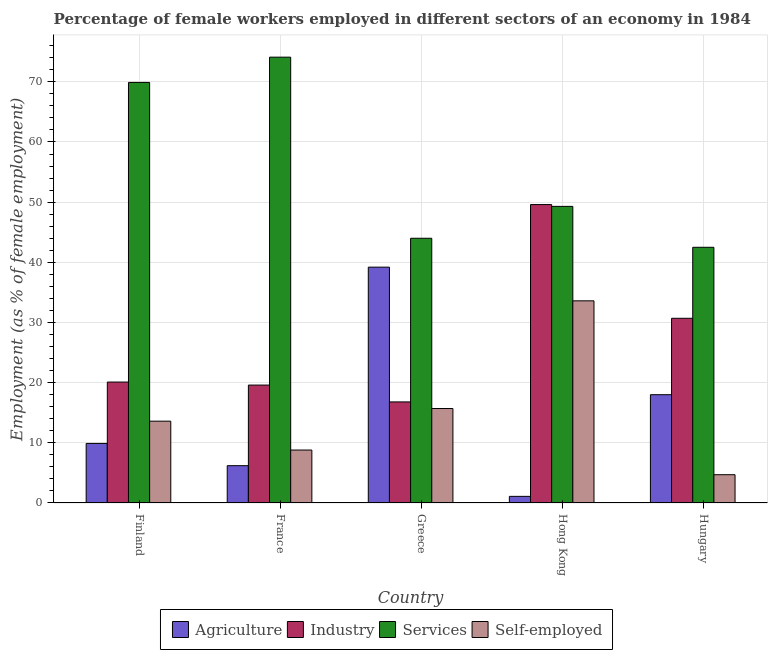Are the number of bars per tick equal to the number of legend labels?
Give a very brief answer. Yes. Are the number of bars on each tick of the X-axis equal?
Offer a terse response. Yes. How many bars are there on the 3rd tick from the right?
Offer a terse response. 4. What is the label of the 4th group of bars from the left?
Give a very brief answer. Hong Kong. In how many cases, is the number of bars for a given country not equal to the number of legend labels?
Make the answer very short. 0. What is the percentage of female workers in industry in Finland?
Your response must be concise. 20.1. Across all countries, what is the maximum percentage of female workers in services?
Your answer should be very brief. 74.1. Across all countries, what is the minimum percentage of female workers in industry?
Give a very brief answer. 16.8. In which country was the percentage of self employed female workers maximum?
Make the answer very short. Hong Kong. In which country was the percentage of female workers in services minimum?
Your answer should be very brief. Hungary. What is the total percentage of self employed female workers in the graph?
Offer a terse response. 76.4. What is the difference between the percentage of self employed female workers in Finland and that in Greece?
Ensure brevity in your answer.  -2.1. What is the difference between the percentage of self employed female workers in Hungary and the percentage of female workers in services in Finland?
Ensure brevity in your answer.  -65.2. What is the average percentage of female workers in agriculture per country?
Give a very brief answer. 14.88. What is the difference between the percentage of female workers in services and percentage of female workers in industry in Greece?
Make the answer very short. 27.2. What is the ratio of the percentage of female workers in services in Finland to that in Hungary?
Your response must be concise. 1.64. Is the percentage of female workers in industry in Finland less than that in Greece?
Provide a short and direct response. No. What is the difference between the highest and the second highest percentage of self employed female workers?
Keep it short and to the point. 17.9. What is the difference between the highest and the lowest percentage of female workers in services?
Make the answer very short. 31.6. Is it the case that in every country, the sum of the percentage of female workers in services and percentage of female workers in industry is greater than the sum of percentage of self employed female workers and percentage of female workers in agriculture?
Offer a very short reply. Yes. What does the 2nd bar from the left in Greece represents?
Provide a short and direct response. Industry. What does the 4th bar from the right in Greece represents?
Give a very brief answer. Agriculture. Are all the bars in the graph horizontal?
Give a very brief answer. No. What is the difference between two consecutive major ticks on the Y-axis?
Make the answer very short. 10. Are the values on the major ticks of Y-axis written in scientific E-notation?
Give a very brief answer. No. Does the graph contain grids?
Offer a very short reply. Yes. Where does the legend appear in the graph?
Give a very brief answer. Bottom center. How many legend labels are there?
Offer a very short reply. 4. What is the title of the graph?
Your answer should be very brief. Percentage of female workers employed in different sectors of an economy in 1984. Does "CO2 damage" appear as one of the legend labels in the graph?
Offer a terse response. No. What is the label or title of the Y-axis?
Your response must be concise. Employment (as % of female employment). What is the Employment (as % of female employment) of Agriculture in Finland?
Your answer should be very brief. 9.9. What is the Employment (as % of female employment) of Industry in Finland?
Your response must be concise. 20.1. What is the Employment (as % of female employment) in Services in Finland?
Your answer should be compact. 69.9. What is the Employment (as % of female employment) of Self-employed in Finland?
Provide a succinct answer. 13.6. What is the Employment (as % of female employment) of Agriculture in France?
Your answer should be compact. 6.2. What is the Employment (as % of female employment) of Industry in France?
Keep it short and to the point. 19.6. What is the Employment (as % of female employment) of Services in France?
Your response must be concise. 74.1. What is the Employment (as % of female employment) of Self-employed in France?
Your answer should be very brief. 8.8. What is the Employment (as % of female employment) in Agriculture in Greece?
Ensure brevity in your answer.  39.2. What is the Employment (as % of female employment) in Industry in Greece?
Provide a short and direct response. 16.8. What is the Employment (as % of female employment) of Services in Greece?
Your answer should be very brief. 44. What is the Employment (as % of female employment) of Self-employed in Greece?
Provide a short and direct response. 15.7. What is the Employment (as % of female employment) in Agriculture in Hong Kong?
Provide a succinct answer. 1.1. What is the Employment (as % of female employment) in Industry in Hong Kong?
Ensure brevity in your answer.  49.6. What is the Employment (as % of female employment) in Services in Hong Kong?
Keep it short and to the point. 49.3. What is the Employment (as % of female employment) of Self-employed in Hong Kong?
Give a very brief answer. 33.6. What is the Employment (as % of female employment) of Agriculture in Hungary?
Provide a short and direct response. 18. What is the Employment (as % of female employment) of Industry in Hungary?
Your answer should be compact. 30.7. What is the Employment (as % of female employment) in Services in Hungary?
Keep it short and to the point. 42.5. What is the Employment (as % of female employment) of Self-employed in Hungary?
Provide a succinct answer. 4.7. Across all countries, what is the maximum Employment (as % of female employment) of Agriculture?
Provide a succinct answer. 39.2. Across all countries, what is the maximum Employment (as % of female employment) in Industry?
Your answer should be very brief. 49.6. Across all countries, what is the maximum Employment (as % of female employment) of Services?
Provide a short and direct response. 74.1. Across all countries, what is the maximum Employment (as % of female employment) of Self-employed?
Keep it short and to the point. 33.6. Across all countries, what is the minimum Employment (as % of female employment) of Agriculture?
Give a very brief answer. 1.1. Across all countries, what is the minimum Employment (as % of female employment) of Industry?
Your response must be concise. 16.8. Across all countries, what is the minimum Employment (as % of female employment) in Services?
Your answer should be compact. 42.5. Across all countries, what is the minimum Employment (as % of female employment) in Self-employed?
Give a very brief answer. 4.7. What is the total Employment (as % of female employment) in Agriculture in the graph?
Offer a terse response. 74.4. What is the total Employment (as % of female employment) in Industry in the graph?
Ensure brevity in your answer.  136.8. What is the total Employment (as % of female employment) of Services in the graph?
Your answer should be very brief. 279.8. What is the total Employment (as % of female employment) in Self-employed in the graph?
Your response must be concise. 76.4. What is the difference between the Employment (as % of female employment) in Agriculture in Finland and that in France?
Give a very brief answer. 3.7. What is the difference between the Employment (as % of female employment) in Services in Finland and that in France?
Offer a very short reply. -4.2. What is the difference between the Employment (as % of female employment) in Self-employed in Finland and that in France?
Offer a very short reply. 4.8. What is the difference between the Employment (as % of female employment) of Agriculture in Finland and that in Greece?
Ensure brevity in your answer.  -29.3. What is the difference between the Employment (as % of female employment) in Services in Finland and that in Greece?
Your answer should be very brief. 25.9. What is the difference between the Employment (as % of female employment) of Industry in Finland and that in Hong Kong?
Make the answer very short. -29.5. What is the difference between the Employment (as % of female employment) of Services in Finland and that in Hong Kong?
Give a very brief answer. 20.6. What is the difference between the Employment (as % of female employment) in Agriculture in Finland and that in Hungary?
Your answer should be very brief. -8.1. What is the difference between the Employment (as % of female employment) of Services in Finland and that in Hungary?
Offer a terse response. 27.4. What is the difference between the Employment (as % of female employment) of Self-employed in Finland and that in Hungary?
Keep it short and to the point. 8.9. What is the difference between the Employment (as % of female employment) of Agriculture in France and that in Greece?
Provide a succinct answer. -33. What is the difference between the Employment (as % of female employment) in Services in France and that in Greece?
Ensure brevity in your answer.  30.1. What is the difference between the Employment (as % of female employment) of Agriculture in France and that in Hong Kong?
Your answer should be compact. 5.1. What is the difference between the Employment (as % of female employment) of Industry in France and that in Hong Kong?
Give a very brief answer. -30. What is the difference between the Employment (as % of female employment) in Services in France and that in Hong Kong?
Your response must be concise. 24.8. What is the difference between the Employment (as % of female employment) in Self-employed in France and that in Hong Kong?
Give a very brief answer. -24.8. What is the difference between the Employment (as % of female employment) in Services in France and that in Hungary?
Your response must be concise. 31.6. What is the difference between the Employment (as % of female employment) in Self-employed in France and that in Hungary?
Provide a short and direct response. 4.1. What is the difference between the Employment (as % of female employment) in Agriculture in Greece and that in Hong Kong?
Offer a very short reply. 38.1. What is the difference between the Employment (as % of female employment) in Industry in Greece and that in Hong Kong?
Ensure brevity in your answer.  -32.8. What is the difference between the Employment (as % of female employment) of Services in Greece and that in Hong Kong?
Provide a succinct answer. -5.3. What is the difference between the Employment (as % of female employment) in Self-employed in Greece and that in Hong Kong?
Provide a short and direct response. -17.9. What is the difference between the Employment (as % of female employment) of Agriculture in Greece and that in Hungary?
Provide a short and direct response. 21.2. What is the difference between the Employment (as % of female employment) in Services in Greece and that in Hungary?
Provide a succinct answer. 1.5. What is the difference between the Employment (as % of female employment) in Agriculture in Hong Kong and that in Hungary?
Give a very brief answer. -16.9. What is the difference between the Employment (as % of female employment) in Industry in Hong Kong and that in Hungary?
Offer a terse response. 18.9. What is the difference between the Employment (as % of female employment) of Self-employed in Hong Kong and that in Hungary?
Your answer should be very brief. 28.9. What is the difference between the Employment (as % of female employment) of Agriculture in Finland and the Employment (as % of female employment) of Industry in France?
Ensure brevity in your answer.  -9.7. What is the difference between the Employment (as % of female employment) in Agriculture in Finland and the Employment (as % of female employment) in Services in France?
Keep it short and to the point. -64.2. What is the difference between the Employment (as % of female employment) of Industry in Finland and the Employment (as % of female employment) of Services in France?
Provide a short and direct response. -54. What is the difference between the Employment (as % of female employment) of Industry in Finland and the Employment (as % of female employment) of Self-employed in France?
Your response must be concise. 11.3. What is the difference between the Employment (as % of female employment) of Services in Finland and the Employment (as % of female employment) of Self-employed in France?
Provide a short and direct response. 61.1. What is the difference between the Employment (as % of female employment) of Agriculture in Finland and the Employment (as % of female employment) of Industry in Greece?
Provide a short and direct response. -6.9. What is the difference between the Employment (as % of female employment) of Agriculture in Finland and the Employment (as % of female employment) of Services in Greece?
Ensure brevity in your answer.  -34.1. What is the difference between the Employment (as % of female employment) of Industry in Finland and the Employment (as % of female employment) of Services in Greece?
Offer a terse response. -23.9. What is the difference between the Employment (as % of female employment) in Industry in Finland and the Employment (as % of female employment) in Self-employed in Greece?
Offer a very short reply. 4.4. What is the difference between the Employment (as % of female employment) of Services in Finland and the Employment (as % of female employment) of Self-employed in Greece?
Offer a very short reply. 54.2. What is the difference between the Employment (as % of female employment) of Agriculture in Finland and the Employment (as % of female employment) of Industry in Hong Kong?
Offer a very short reply. -39.7. What is the difference between the Employment (as % of female employment) of Agriculture in Finland and the Employment (as % of female employment) of Services in Hong Kong?
Keep it short and to the point. -39.4. What is the difference between the Employment (as % of female employment) of Agriculture in Finland and the Employment (as % of female employment) of Self-employed in Hong Kong?
Your answer should be compact. -23.7. What is the difference between the Employment (as % of female employment) of Industry in Finland and the Employment (as % of female employment) of Services in Hong Kong?
Offer a terse response. -29.2. What is the difference between the Employment (as % of female employment) of Services in Finland and the Employment (as % of female employment) of Self-employed in Hong Kong?
Your answer should be compact. 36.3. What is the difference between the Employment (as % of female employment) in Agriculture in Finland and the Employment (as % of female employment) in Industry in Hungary?
Provide a short and direct response. -20.8. What is the difference between the Employment (as % of female employment) of Agriculture in Finland and the Employment (as % of female employment) of Services in Hungary?
Provide a short and direct response. -32.6. What is the difference between the Employment (as % of female employment) of Industry in Finland and the Employment (as % of female employment) of Services in Hungary?
Keep it short and to the point. -22.4. What is the difference between the Employment (as % of female employment) of Industry in Finland and the Employment (as % of female employment) of Self-employed in Hungary?
Ensure brevity in your answer.  15.4. What is the difference between the Employment (as % of female employment) in Services in Finland and the Employment (as % of female employment) in Self-employed in Hungary?
Make the answer very short. 65.2. What is the difference between the Employment (as % of female employment) of Agriculture in France and the Employment (as % of female employment) of Services in Greece?
Make the answer very short. -37.8. What is the difference between the Employment (as % of female employment) of Agriculture in France and the Employment (as % of female employment) of Self-employed in Greece?
Provide a short and direct response. -9.5. What is the difference between the Employment (as % of female employment) of Industry in France and the Employment (as % of female employment) of Services in Greece?
Offer a terse response. -24.4. What is the difference between the Employment (as % of female employment) of Industry in France and the Employment (as % of female employment) of Self-employed in Greece?
Make the answer very short. 3.9. What is the difference between the Employment (as % of female employment) in Services in France and the Employment (as % of female employment) in Self-employed in Greece?
Make the answer very short. 58.4. What is the difference between the Employment (as % of female employment) of Agriculture in France and the Employment (as % of female employment) of Industry in Hong Kong?
Make the answer very short. -43.4. What is the difference between the Employment (as % of female employment) of Agriculture in France and the Employment (as % of female employment) of Services in Hong Kong?
Offer a terse response. -43.1. What is the difference between the Employment (as % of female employment) of Agriculture in France and the Employment (as % of female employment) of Self-employed in Hong Kong?
Give a very brief answer. -27.4. What is the difference between the Employment (as % of female employment) in Industry in France and the Employment (as % of female employment) in Services in Hong Kong?
Ensure brevity in your answer.  -29.7. What is the difference between the Employment (as % of female employment) in Services in France and the Employment (as % of female employment) in Self-employed in Hong Kong?
Your answer should be compact. 40.5. What is the difference between the Employment (as % of female employment) in Agriculture in France and the Employment (as % of female employment) in Industry in Hungary?
Provide a succinct answer. -24.5. What is the difference between the Employment (as % of female employment) in Agriculture in France and the Employment (as % of female employment) in Services in Hungary?
Provide a succinct answer. -36.3. What is the difference between the Employment (as % of female employment) of Industry in France and the Employment (as % of female employment) of Services in Hungary?
Your answer should be compact. -22.9. What is the difference between the Employment (as % of female employment) in Services in France and the Employment (as % of female employment) in Self-employed in Hungary?
Your answer should be compact. 69.4. What is the difference between the Employment (as % of female employment) of Agriculture in Greece and the Employment (as % of female employment) of Services in Hong Kong?
Your response must be concise. -10.1. What is the difference between the Employment (as % of female employment) in Industry in Greece and the Employment (as % of female employment) in Services in Hong Kong?
Make the answer very short. -32.5. What is the difference between the Employment (as % of female employment) of Industry in Greece and the Employment (as % of female employment) of Self-employed in Hong Kong?
Give a very brief answer. -16.8. What is the difference between the Employment (as % of female employment) of Services in Greece and the Employment (as % of female employment) of Self-employed in Hong Kong?
Offer a very short reply. 10.4. What is the difference between the Employment (as % of female employment) in Agriculture in Greece and the Employment (as % of female employment) in Self-employed in Hungary?
Your answer should be very brief. 34.5. What is the difference between the Employment (as % of female employment) of Industry in Greece and the Employment (as % of female employment) of Services in Hungary?
Your answer should be very brief. -25.7. What is the difference between the Employment (as % of female employment) in Industry in Greece and the Employment (as % of female employment) in Self-employed in Hungary?
Give a very brief answer. 12.1. What is the difference between the Employment (as % of female employment) in Services in Greece and the Employment (as % of female employment) in Self-employed in Hungary?
Provide a succinct answer. 39.3. What is the difference between the Employment (as % of female employment) in Agriculture in Hong Kong and the Employment (as % of female employment) in Industry in Hungary?
Make the answer very short. -29.6. What is the difference between the Employment (as % of female employment) in Agriculture in Hong Kong and the Employment (as % of female employment) in Services in Hungary?
Make the answer very short. -41.4. What is the difference between the Employment (as % of female employment) in Industry in Hong Kong and the Employment (as % of female employment) in Self-employed in Hungary?
Provide a succinct answer. 44.9. What is the difference between the Employment (as % of female employment) of Services in Hong Kong and the Employment (as % of female employment) of Self-employed in Hungary?
Give a very brief answer. 44.6. What is the average Employment (as % of female employment) in Agriculture per country?
Give a very brief answer. 14.88. What is the average Employment (as % of female employment) of Industry per country?
Make the answer very short. 27.36. What is the average Employment (as % of female employment) in Services per country?
Offer a terse response. 55.96. What is the average Employment (as % of female employment) of Self-employed per country?
Provide a short and direct response. 15.28. What is the difference between the Employment (as % of female employment) in Agriculture and Employment (as % of female employment) in Services in Finland?
Give a very brief answer. -60. What is the difference between the Employment (as % of female employment) of Industry and Employment (as % of female employment) of Services in Finland?
Ensure brevity in your answer.  -49.8. What is the difference between the Employment (as % of female employment) of Industry and Employment (as % of female employment) of Self-employed in Finland?
Your response must be concise. 6.5. What is the difference between the Employment (as % of female employment) of Services and Employment (as % of female employment) of Self-employed in Finland?
Give a very brief answer. 56.3. What is the difference between the Employment (as % of female employment) of Agriculture and Employment (as % of female employment) of Industry in France?
Your response must be concise. -13.4. What is the difference between the Employment (as % of female employment) in Agriculture and Employment (as % of female employment) in Services in France?
Your answer should be very brief. -67.9. What is the difference between the Employment (as % of female employment) of Industry and Employment (as % of female employment) of Services in France?
Make the answer very short. -54.5. What is the difference between the Employment (as % of female employment) of Services and Employment (as % of female employment) of Self-employed in France?
Offer a very short reply. 65.3. What is the difference between the Employment (as % of female employment) in Agriculture and Employment (as % of female employment) in Industry in Greece?
Ensure brevity in your answer.  22.4. What is the difference between the Employment (as % of female employment) of Agriculture and Employment (as % of female employment) of Services in Greece?
Keep it short and to the point. -4.8. What is the difference between the Employment (as % of female employment) of Agriculture and Employment (as % of female employment) of Self-employed in Greece?
Provide a succinct answer. 23.5. What is the difference between the Employment (as % of female employment) of Industry and Employment (as % of female employment) of Services in Greece?
Your response must be concise. -27.2. What is the difference between the Employment (as % of female employment) of Industry and Employment (as % of female employment) of Self-employed in Greece?
Your answer should be compact. 1.1. What is the difference between the Employment (as % of female employment) of Services and Employment (as % of female employment) of Self-employed in Greece?
Keep it short and to the point. 28.3. What is the difference between the Employment (as % of female employment) of Agriculture and Employment (as % of female employment) of Industry in Hong Kong?
Ensure brevity in your answer.  -48.5. What is the difference between the Employment (as % of female employment) of Agriculture and Employment (as % of female employment) of Services in Hong Kong?
Your answer should be compact. -48.2. What is the difference between the Employment (as % of female employment) of Agriculture and Employment (as % of female employment) of Self-employed in Hong Kong?
Your answer should be compact. -32.5. What is the difference between the Employment (as % of female employment) of Industry and Employment (as % of female employment) of Services in Hong Kong?
Offer a terse response. 0.3. What is the difference between the Employment (as % of female employment) of Industry and Employment (as % of female employment) of Self-employed in Hong Kong?
Provide a succinct answer. 16. What is the difference between the Employment (as % of female employment) of Agriculture and Employment (as % of female employment) of Services in Hungary?
Ensure brevity in your answer.  -24.5. What is the difference between the Employment (as % of female employment) of Agriculture and Employment (as % of female employment) of Self-employed in Hungary?
Offer a terse response. 13.3. What is the difference between the Employment (as % of female employment) of Industry and Employment (as % of female employment) of Self-employed in Hungary?
Offer a terse response. 26. What is the difference between the Employment (as % of female employment) of Services and Employment (as % of female employment) of Self-employed in Hungary?
Make the answer very short. 37.8. What is the ratio of the Employment (as % of female employment) of Agriculture in Finland to that in France?
Your answer should be very brief. 1.6. What is the ratio of the Employment (as % of female employment) of Industry in Finland to that in France?
Your answer should be compact. 1.03. What is the ratio of the Employment (as % of female employment) of Services in Finland to that in France?
Your response must be concise. 0.94. What is the ratio of the Employment (as % of female employment) of Self-employed in Finland to that in France?
Give a very brief answer. 1.55. What is the ratio of the Employment (as % of female employment) of Agriculture in Finland to that in Greece?
Ensure brevity in your answer.  0.25. What is the ratio of the Employment (as % of female employment) of Industry in Finland to that in Greece?
Ensure brevity in your answer.  1.2. What is the ratio of the Employment (as % of female employment) in Services in Finland to that in Greece?
Give a very brief answer. 1.59. What is the ratio of the Employment (as % of female employment) in Self-employed in Finland to that in Greece?
Your response must be concise. 0.87. What is the ratio of the Employment (as % of female employment) of Agriculture in Finland to that in Hong Kong?
Keep it short and to the point. 9. What is the ratio of the Employment (as % of female employment) of Industry in Finland to that in Hong Kong?
Keep it short and to the point. 0.41. What is the ratio of the Employment (as % of female employment) of Services in Finland to that in Hong Kong?
Your answer should be compact. 1.42. What is the ratio of the Employment (as % of female employment) in Self-employed in Finland to that in Hong Kong?
Give a very brief answer. 0.4. What is the ratio of the Employment (as % of female employment) in Agriculture in Finland to that in Hungary?
Offer a very short reply. 0.55. What is the ratio of the Employment (as % of female employment) in Industry in Finland to that in Hungary?
Offer a terse response. 0.65. What is the ratio of the Employment (as % of female employment) in Services in Finland to that in Hungary?
Your answer should be compact. 1.64. What is the ratio of the Employment (as % of female employment) in Self-employed in Finland to that in Hungary?
Your response must be concise. 2.89. What is the ratio of the Employment (as % of female employment) in Agriculture in France to that in Greece?
Make the answer very short. 0.16. What is the ratio of the Employment (as % of female employment) in Industry in France to that in Greece?
Ensure brevity in your answer.  1.17. What is the ratio of the Employment (as % of female employment) of Services in France to that in Greece?
Make the answer very short. 1.68. What is the ratio of the Employment (as % of female employment) in Self-employed in France to that in Greece?
Your answer should be compact. 0.56. What is the ratio of the Employment (as % of female employment) in Agriculture in France to that in Hong Kong?
Your answer should be very brief. 5.64. What is the ratio of the Employment (as % of female employment) in Industry in France to that in Hong Kong?
Make the answer very short. 0.4. What is the ratio of the Employment (as % of female employment) in Services in France to that in Hong Kong?
Keep it short and to the point. 1.5. What is the ratio of the Employment (as % of female employment) in Self-employed in France to that in Hong Kong?
Your answer should be compact. 0.26. What is the ratio of the Employment (as % of female employment) of Agriculture in France to that in Hungary?
Make the answer very short. 0.34. What is the ratio of the Employment (as % of female employment) in Industry in France to that in Hungary?
Ensure brevity in your answer.  0.64. What is the ratio of the Employment (as % of female employment) in Services in France to that in Hungary?
Make the answer very short. 1.74. What is the ratio of the Employment (as % of female employment) in Self-employed in France to that in Hungary?
Provide a succinct answer. 1.87. What is the ratio of the Employment (as % of female employment) in Agriculture in Greece to that in Hong Kong?
Keep it short and to the point. 35.64. What is the ratio of the Employment (as % of female employment) of Industry in Greece to that in Hong Kong?
Your answer should be very brief. 0.34. What is the ratio of the Employment (as % of female employment) of Services in Greece to that in Hong Kong?
Your response must be concise. 0.89. What is the ratio of the Employment (as % of female employment) in Self-employed in Greece to that in Hong Kong?
Provide a short and direct response. 0.47. What is the ratio of the Employment (as % of female employment) in Agriculture in Greece to that in Hungary?
Your answer should be compact. 2.18. What is the ratio of the Employment (as % of female employment) of Industry in Greece to that in Hungary?
Your answer should be very brief. 0.55. What is the ratio of the Employment (as % of female employment) of Services in Greece to that in Hungary?
Keep it short and to the point. 1.04. What is the ratio of the Employment (as % of female employment) in Self-employed in Greece to that in Hungary?
Your response must be concise. 3.34. What is the ratio of the Employment (as % of female employment) in Agriculture in Hong Kong to that in Hungary?
Your answer should be compact. 0.06. What is the ratio of the Employment (as % of female employment) of Industry in Hong Kong to that in Hungary?
Offer a very short reply. 1.62. What is the ratio of the Employment (as % of female employment) of Services in Hong Kong to that in Hungary?
Offer a terse response. 1.16. What is the ratio of the Employment (as % of female employment) in Self-employed in Hong Kong to that in Hungary?
Make the answer very short. 7.15. What is the difference between the highest and the second highest Employment (as % of female employment) of Agriculture?
Your answer should be very brief. 21.2. What is the difference between the highest and the second highest Employment (as % of female employment) of Self-employed?
Keep it short and to the point. 17.9. What is the difference between the highest and the lowest Employment (as % of female employment) of Agriculture?
Make the answer very short. 38.1. What is the difference between the highest and the lowest Employment (as % of female employment) in Industry?
Ensure brevity in your answer.  32.8. What is the difference between the highest and the lowest Employment (as % of female employment) of Services?
Offer a very short reply. 31.6. What is the difference between the highest and the lowest Employment (as % of female employment) of Self-employed?
Offer a very short reply. 28.9. 